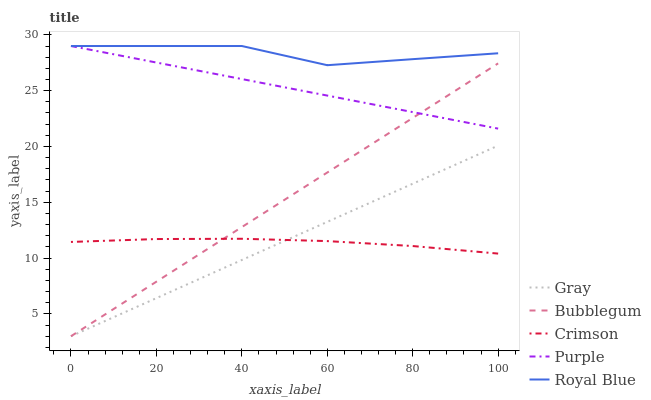Does Gray have the minimum area under the curve?
Answer yes or no. No. Does Gray have the maximum area under the curve?
Answer yes or no. No. Is Purple the smoothest?
Answer yes or no. No. Is Purple the roughest?
Answer yes or no. No. Does Purple have the lowest value?
Answer yes or no. No. Does Gray have the highest value?
Answer yes or no. No. Is Crimson less than Royal Blue?
Answer yes or no. Yes. Is Royal Blue greater than Gray?
Answer yes or no. Yes. Does Crimson intersect Royal Blue?
Answer yes or no. No. 